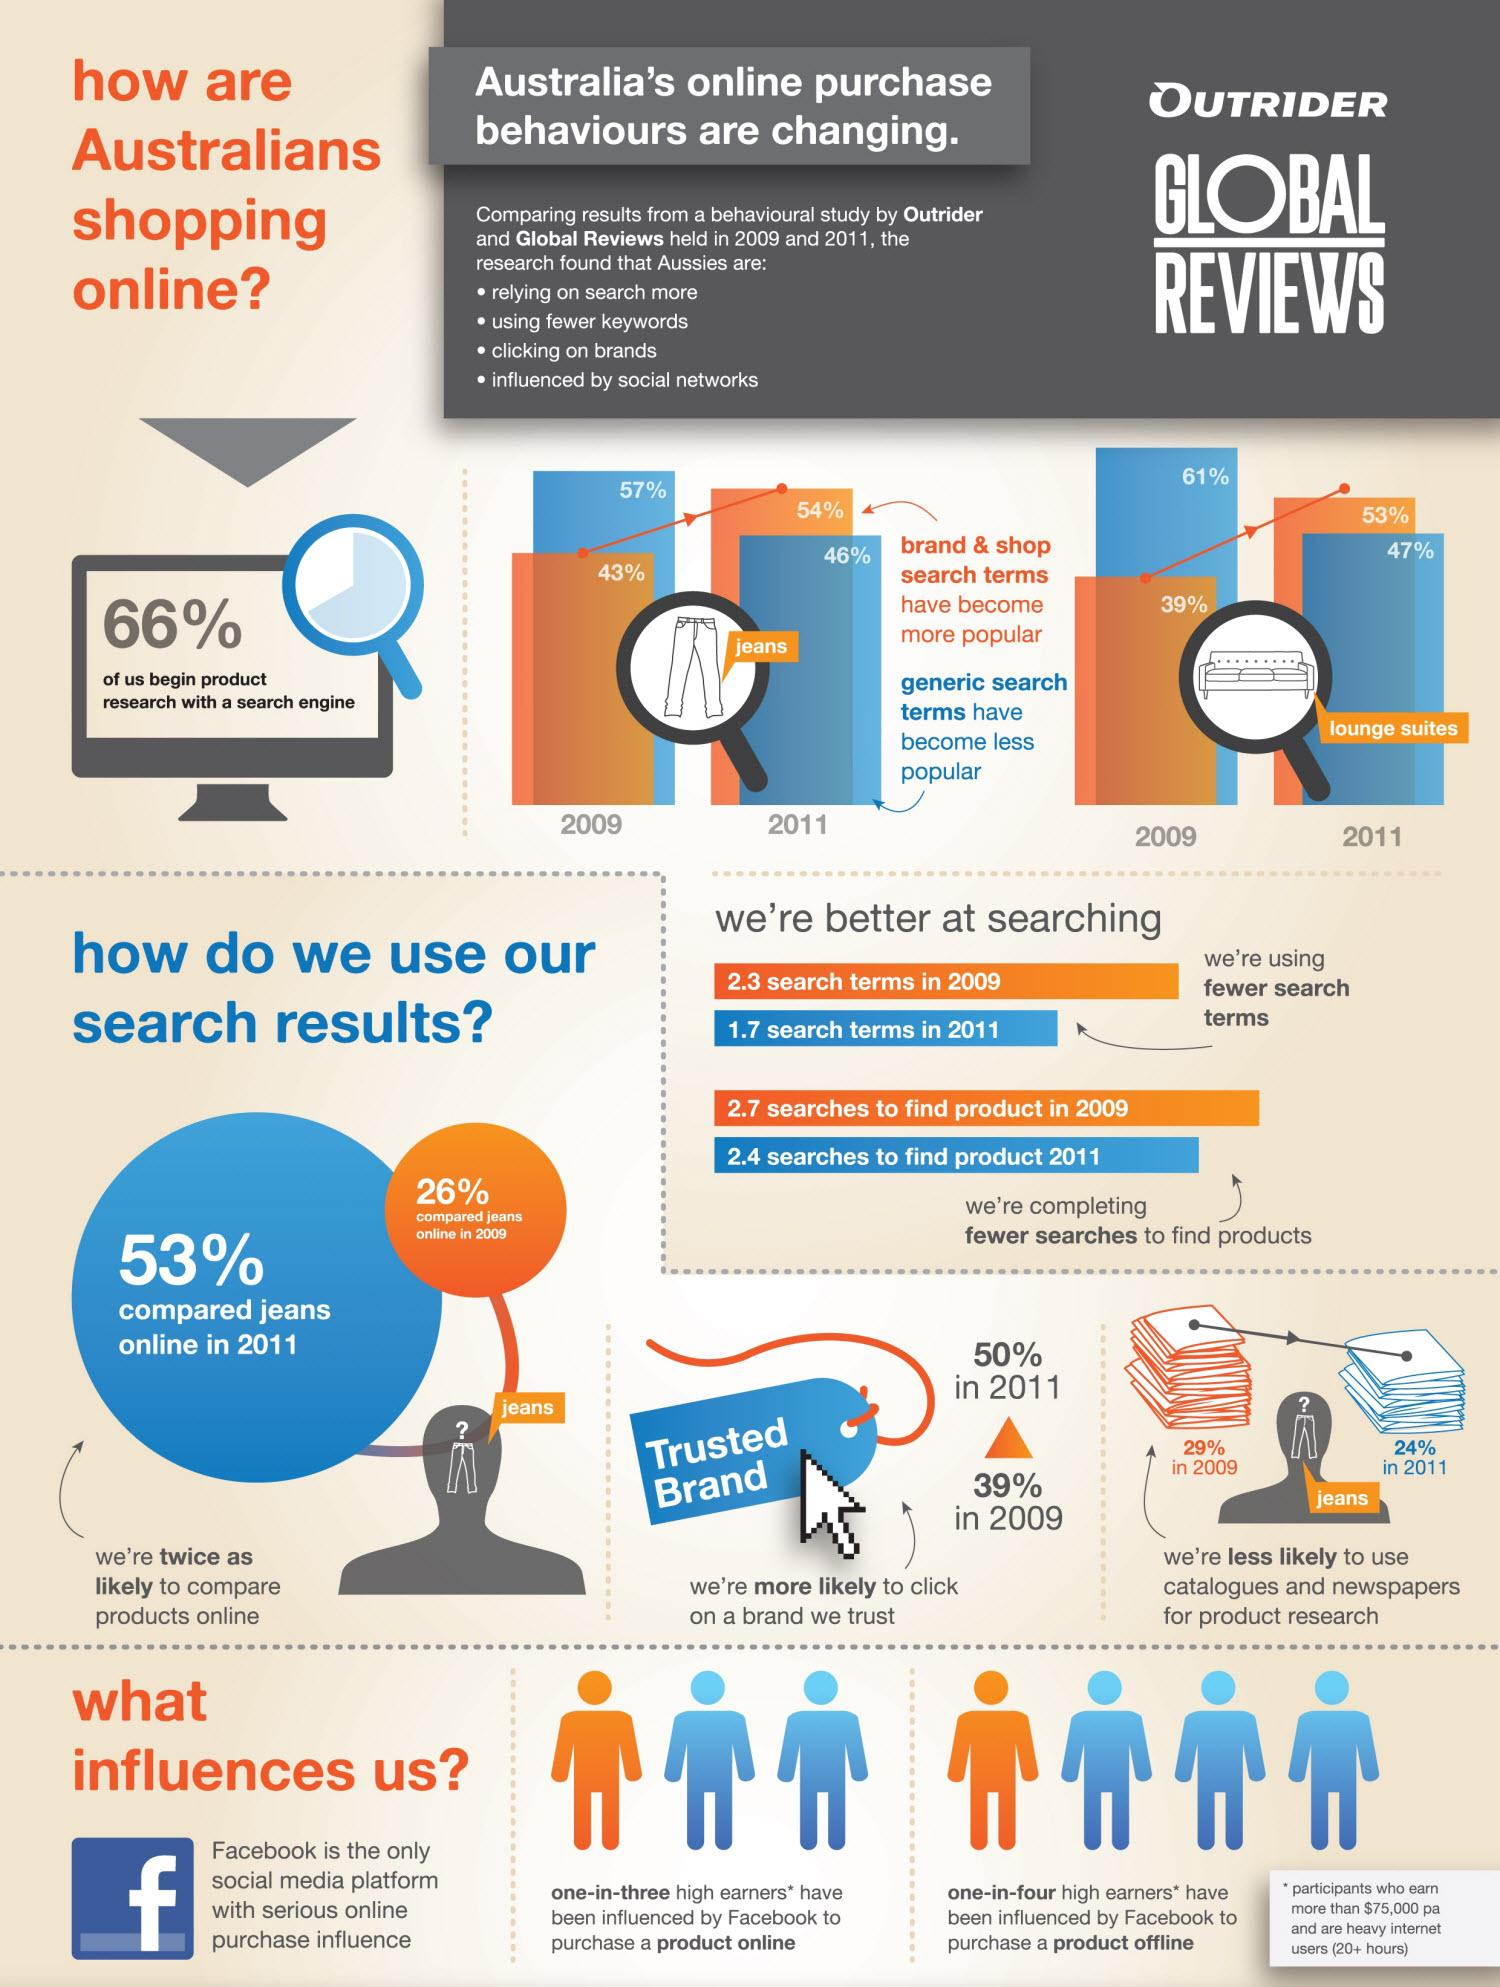Give some essential details in this illustration. In 2009 or 2011, a higher number of search terms was used compared to other years. In 2011, a higher percentage of people clicked on a trusted brand than in 2009. The number of searches for products was higher in 2009 compared to 2011. According to a recent survey, one-in-three people have been influenced by Facebook to make an online purchase. In 2009, a lower percentage of people compared products online compared to 2011. 